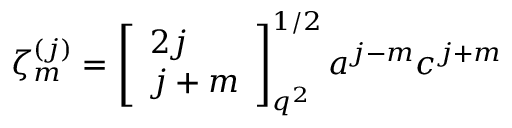Convert formula to latex. <formula><loc_0><loc_0><loc_500><loc_500>\zeta _ { m } ^ { ( j ) } = \left [ \begin{array} { l } { 2 j } \\ { j + m } \end{array} \right ] _ { q ^ { 2 } } ^ { 1 / 2 } a ^ { j - m } c ^ { j + m }</formula> 